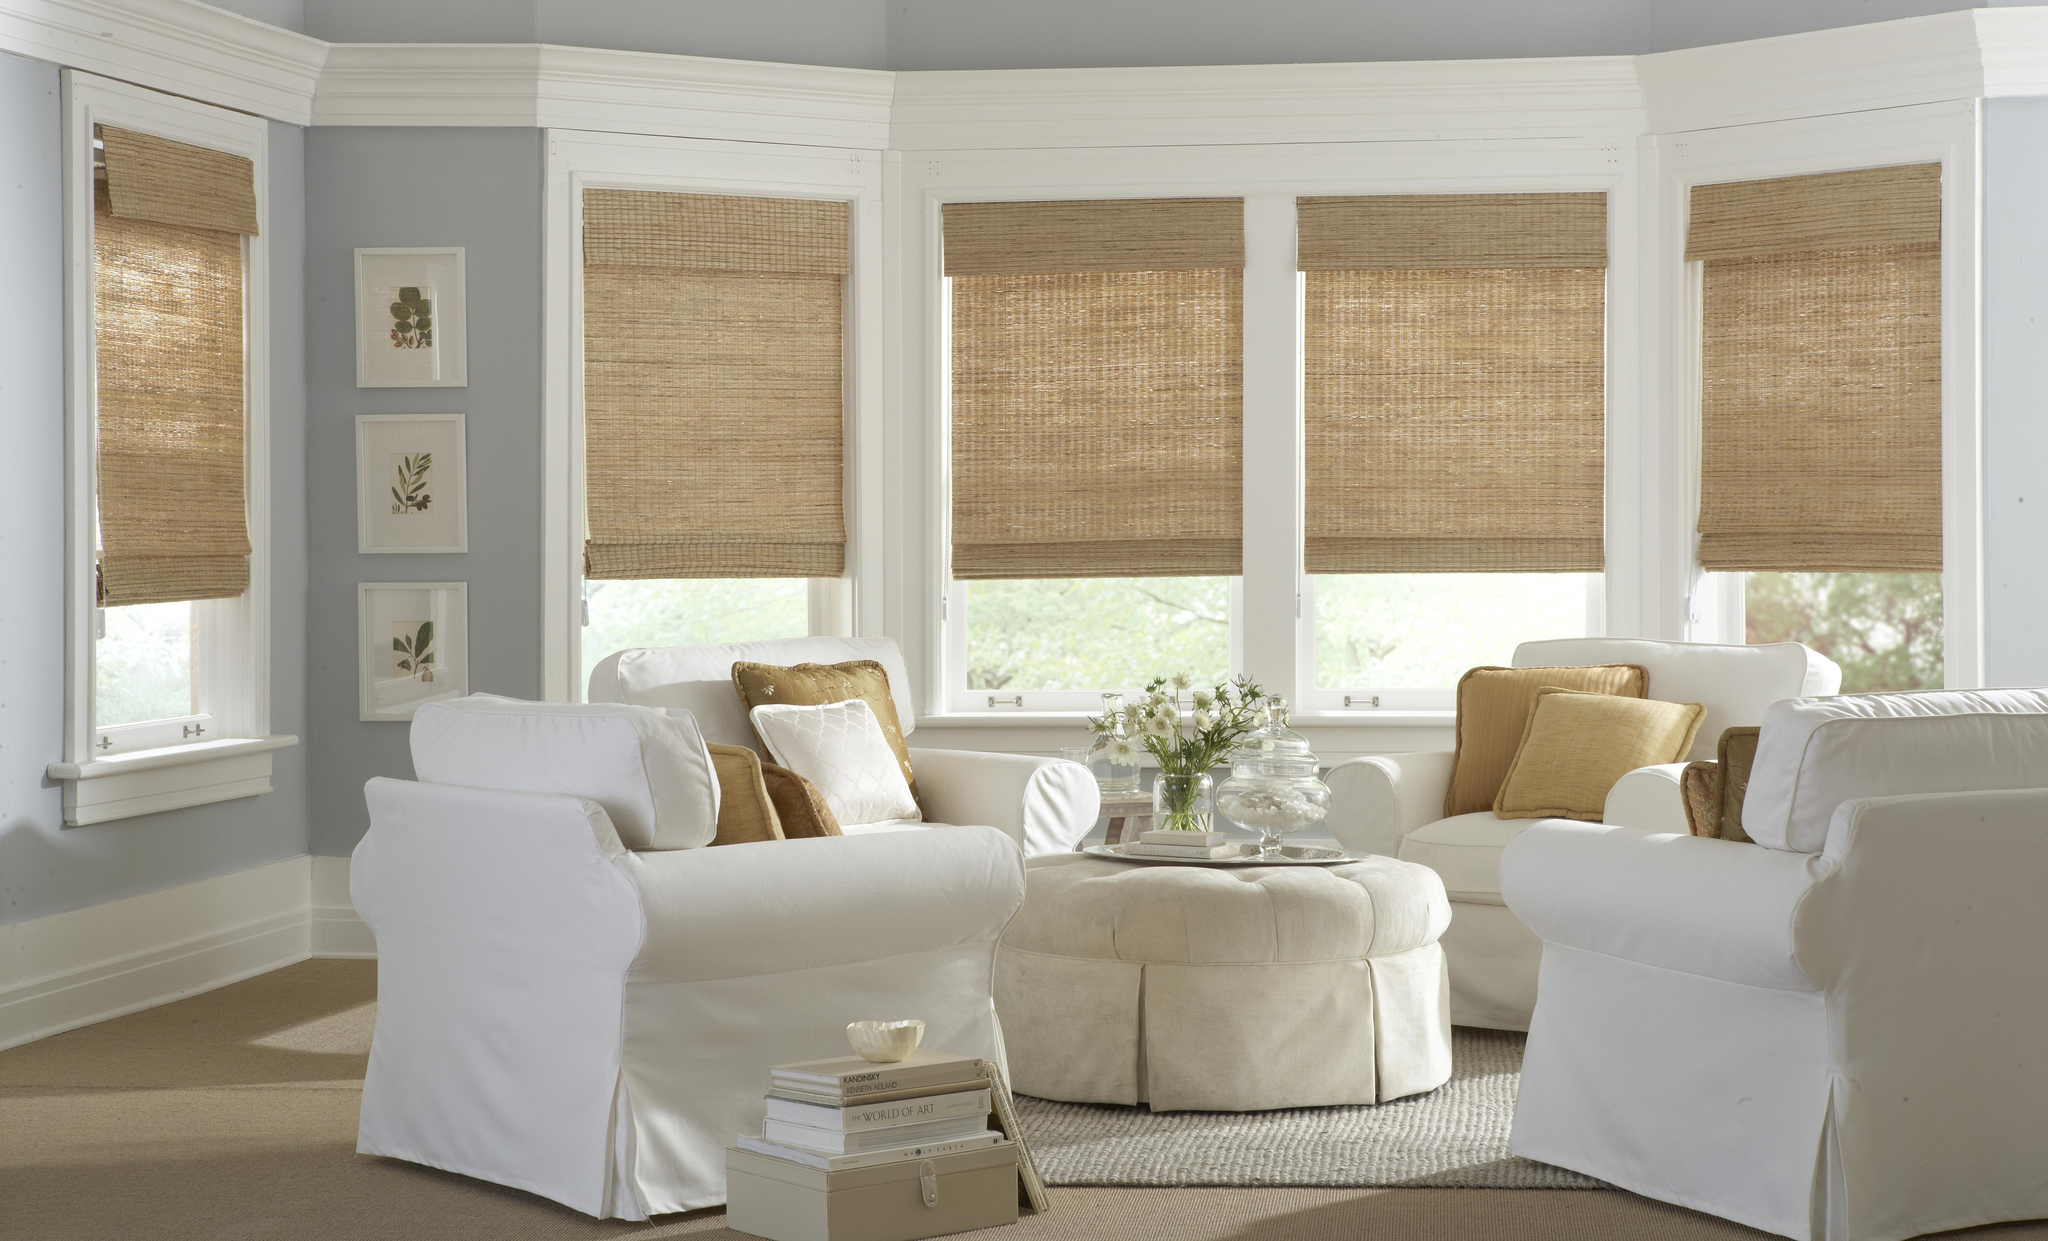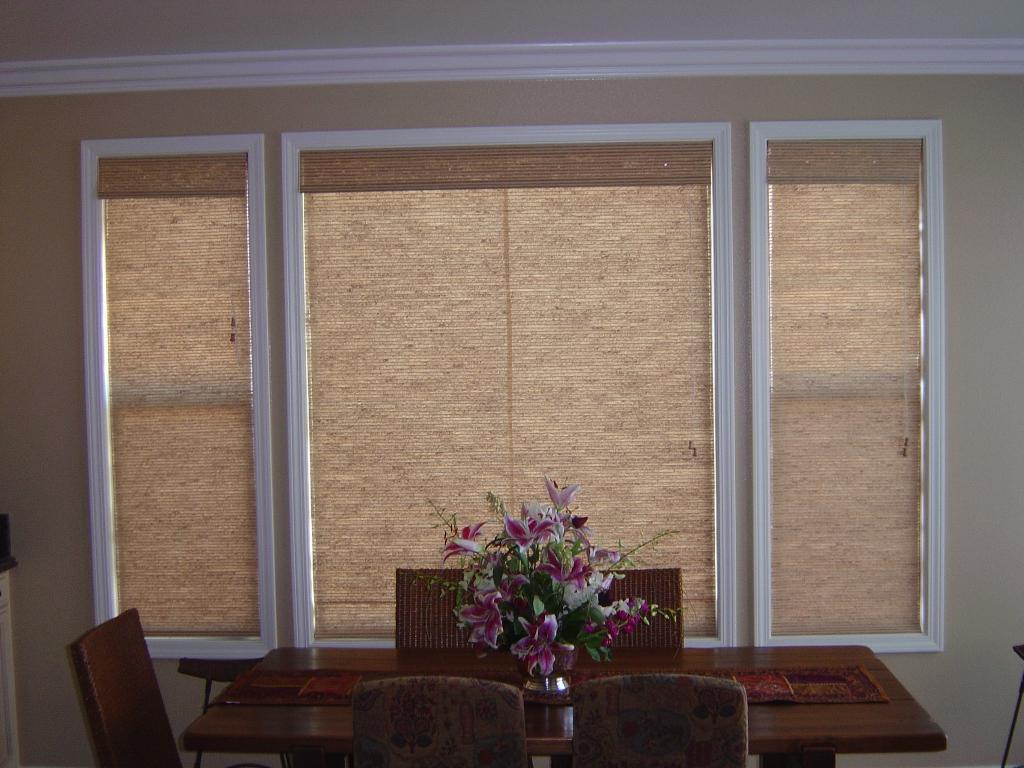The first image is the image on the left, the second image is the image on the right. For the images displayed, is the sentence "A couch is backed up against a row of windows in one of the images." factually correct? Answer yes or no. No. 